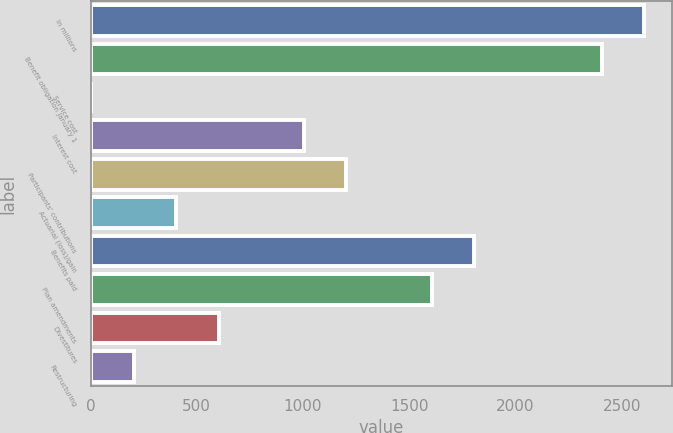<chart> <loc_0><loc_0><loc_500><loc_500><bar_chart><fcel>In millions<fcel>Benefit obligation January 1<fcel>Service cost<fcel>Interest cost<fcel>Participants' contributions<fcel>Actuarial (loss)/gain<fcel>Benefits paid<fcel>Plan amendments<fcel>Divestitures<fcel>Restructuring<nl><fcel>2607.2<fcel>2406.8<fcel>2<fcel>1004<fcel>1204.4<fcel>402.8<fcel>1805.6<fcel>1605.2<fcel>603.2<fcel>202.4<nl></chart> 